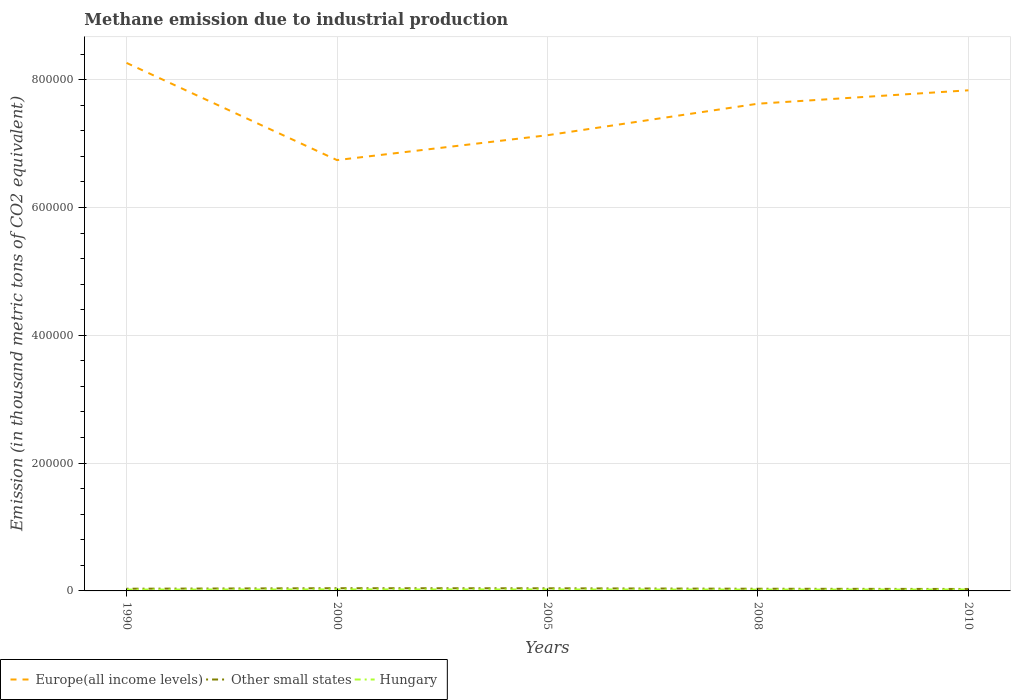How many different coloured lines are there?
Ensure brevity in your answer.  3. Does the line corresponding to Other small states intersect with the line corresponding to Hungary?
Your answer should be compact. No. Across all years, what is the maximum amount of methane emitted in Hungary?
Your answer should be compact. 2124.8. In which year was the amount of methane emitted in Europe(all income levels) maximum?
Provide a succinct answer. 2000. What is the total amount of methane emitted in Hungary in the graph?
Your answer should be compact. -249.9. What is the difference between the highest and the second highest amount of methane emitted in Europe(all income levels)?
Your answer should be compact. 1.52e+05. Is the amount of methane emitted in Europe(all income levels) strictly greater than the amount of methane emitted in Other small states over the years?
Keep it short and to the point. No. How many years are there in the graph?
Offer a very short reply. 5. What is the difference between two consecutive major ticks on the Y-axis?
Your response must be concise. 2.00e+05. Are the values on the major ticks of Y-axis written in scientific E-notation?
Ensure brevity in your answer.  No. Does the graph contain grids?
Your answer should be compact. Yes. What is the title of the graph?
Offer a very short reply. Methane emission due to industrial production. Does "France" appear as one of the legend labels in the graph?
Make the answer very short. No. What is the label or title of the Y-axis?
Ensure brevity in your answer.  Emission (in thousand metric tons of CO2 equivalent). What is the Emission (in thousand metric tons of CO2 equivalent) in Europe(all income levels) in 1990?
Provide a succinct answer. 8.26e+05. What is the Emission (in thousand metric tons of CO2 equivalent) in Other small states in 1990?
Keep it short and to the point. 3443.7. What is the Emission (in thousand metric tons of CO2 equivalent) of Hungary in 1990?
Give a very brief answer. 2124.8. What is the Emission (in thousand metric tons of CO2 equivalent) in Europe(all income levels) in 2000?
Offer a very short reply. 6.74e+05. What is the Emission (in thousand metric tons of CO2 equivalent) in Other small states in 2000?
Your response must be concise. 4229.4. What is the Emission (in thousand metric tons of CO2 equivalent) in Hungary in 2000?
Offer a terse response. 2374.7. What is the Emission (in thousand metric tons of CO2 equivalent) in Europe(all income levels) in 2005?
Keep it short and to the point. 7.13e+05. What is the Emission (in thousand metric tons of CO2 equivalent) of Other small states in 2005?
Ensure brevity in your answer.  4102.8. What is the Emission (in thousand metric tons of CO2 equivalent) in Hungary in 2005?
Keep it short and to the point. 2316.5. What is the Emission (in thousand metric tons of CO2 equivalent) of Europe(all income levels) in 2008?
Ensure brevity in your answer.  7.62e+05. What is the Emission (in thousand metric tons of CO2 equivalent) of Other small states in 2008?
Provide a short and direct response. 3410. What is the Emission (in thousand metric tons of CO2 equivalent) in Hungary in 2008?
Offer a terse response. 2129.8. What is the Emission (in thousand metric tons of CO2 equivalent) of Europe(all income levels) in 2010?
Keep it short and to the point. 7.83e+05. What is the Emission (in thousand metric tons of CO2 equivalent) of Other small states in 2010?
Offer a very short reply. 3052.1. What is the Emission (in thousand metric tons of CO2 equivalent) in Hungary in 2010?
Keep it short and to the point. 2241.2. Across all years, what is the maximum Emission (in thousand metric tons of CO2 equivalent) in Europe(all income levels)?
Make the answer very short. 8.26e+05. Across all years, what is the maximum Emission (in thousand metric tons of CO2 equivalent) in Other small states?
Provide a succinct answer. 4229.4. Across all years, what is the maximum Emission (in thousand metric tons of CO2 equivalent) in Hungary?
Make the answer very short. 2374.7. Across all years, what is the minimum Emission (in thousand metric tons of CO2 equivalent) in Europe(all income levels)?
Make the answer very short. 6.74e+05. Across all years, what is the minimum Emission (in thousand metric tons of CO2 equivalent) in Other small states?
Offer a terse response. 3052.1. Across all years, what is the minimum Emission (in thousand metric tons of CO2 equivalent) in Hungary?
Give a very brief answer. 2124.8. What is the total Emission (in thousand metric tons of CO2 equivalent) in Europe(all income levels) in the graph?
Offer a very short reply. 3.76e+06. What is the total Emission (in thousand metric tons of CO2 equivalent) of Other small states in the graph?
Ensure brevity in your answer.  1.82e+04. What is the total Emission (in thousand metric tons of CO2 equivalent) of Hungary in the graph?
Offer a very short reply. 1.12e+04. What is the difference between the Emission (in thousand metric tons of CO2 equivalent) in Europe(all income levels) in 1990 and that in 2000?
Provide a short and direct response. 1.52e+05. What is the difference between the Emission (in thousand metric tons of CO2 equivalent) of Other small states in 1990 and that in 2000?
Your answer should be very brief. -785.7. What is the difference between the Emission (in thousand metric tons of CO2 equivalent) of Hungary in 1990 and that in 2000?
Your response must be concise. -249.9. What is the difference between the Emission (in thousand metric tons of CO2 equivalent) in Europe(all income levels) in 1990 and that in 2005?
Your answer should be compact. 1.13e+05. What is the difference between the Emission (in thousand metric tons of CO2 equivalent) of Other small states in 1990 and that in 2005?
Provide a succinct answer. -659.1. What is the difference between the Emission (in thousand metric tons of CO2 equivalent) of Hungary in 1990 and that in 2005?
Provide a short and direct response. -191.7. What is the difference between the Emission (in thousand metric tons of CO2 equivalent) in Europe(all income levels) in 1990 and that in 2008?
Offer a very short reply. 6.38e+04. What is the difference between the Emission (in thousand metric tons of CO2 equivalent) in Other small states in 1990 and that in 2008?
Make the answer very short. 33.7. What is the difference between the Emission (in thousand metric tons of CO2 equivalent) of Europe(all income levels) in 1990 and that in 2010?
Your response must be concise. 4.29e+04. What is the difference between the Emission (in thousand metric tons of CO2 equivalent) in Other small states in 1990 and that in 2010?
Give a very brief answer. 391.6. What is the difference between the Emission (in thousand metric tons of CO2 equivalent) in Hungary in 1990 and that in 2010?
Keep it short and to the point. -116.4. What is the difference between the Emission (in thousand metric tons of CO2 equivalent) in Europe(all income levels) in 2000 and that in 2005?
Ensure brevity in your answer.  -3.89e+04. What is the difference between the Emission (in thousand metric tons of CO2 equivalent) of Other small states in 2000 and that in 2005?
Provide a short and direct response. 126.6. What is the difference between the Emission (in thousand metric tons of CO2 equivalent) in Hungary in 2000 and that in 2005?
Provide a succinct answer. 58.2. What is the difference between the Emission (in thousand metric tons of CO2 equivalent) in Europe(all income levels) in 2000 and that in 2008?
Offer a very short reply. -8.82e+04. What is the difference between the Emission (in thousand metric tons of CO2 equivalent) in Other small states in 2000 and that in 2008?
Ensure brevity in your answer.  819.4. What is the difference between the Emission (in thousand metric tons of CO2 equivalent) of Hungary in 2000 and that in 2008?
Provide a short and direct response. 244.9. What is the difference between the Emission (in thousand metric tons of CO2 equivalent) in Europe(all income levels) in 2000 and that in 2010?
Your answer should be very brief. -1.09e+05. What is the difference between the Emission (in thousand metric tons of CO2 equivalent) of Other small states in 2000 and that in 2010?
Offer a terse response. 1177.3. What is the difference between the Emission (in thousand metric tons of CO2 equivalent) of Hungary in 2000 and that in 2010?
Make the answer very short. 133.5. What is the difference between the Emission (in thousand metric tons of CO2 equivalent) of Europe(all income levels) in 2005 and that in 2008?
Keep it short and to the point. -4.93e+04. What is the difference between the Emission (in thousand metric tons of CO2 equivalent) in Other small states in 2005 and that in 2008?
Your answer should be very brief. 692.8. What is the difference between the Emission (in thousand metric tons of CO2 equivalent) of Hungary in 2005 and that in 2008?
Offer a terse response. 186.7. What is the difference between the Emission (in thousand metric tons of CO2 equivalent) of Europe(all income levels) in 2005 and that in 2010?
Your answer should be compact. -7.03e+04. What is the difference between the Emission (in thousand metric tons of CO2 equivalent) in Other small states in 2005 and that in 2010?
Keep it short and to the point. 1050.7. What is the difference between the Emission (in thousand metric tons of CO2 equivalent) of Hungary in 2005 and that in 2010?
Your answer should be compact. 75.3. What is the difference between the Emission (in thousand metric tons of CO2 equivalent) of Europe(all income levels) in 2008 and that in 2010?
Your answer should be compact. -2.10e+04. What is the difference between the Emission (in thousand metric tons of CO2 equivalent) of Other small states in 2008 and that in 2010?
Provide a succinct answer. 357.9. What is the difference between the Emission (in thousand metric tons of CO2 equivalent) of Hungary in 2008 and that in 2010?
Provide a short and direct response. -111.4. What is the difference between the Emission (in thousand metric tons of CO2 equivalent) in Europe(all income levels) in 1990 and the Emission (in thousand metric tons of CO2 equivalent) in Other small states in 2000?
Your answer should be compact. 8.22e+05. What is the difference between the Emission (in thousand metric tons of CO2 equivalent) in Europe(all income levels) in 1990 and the Emission (in thousand metric tons of CO2 equivalent) in Hungary in 2000?
Offer a very short reply. 8.24e+05. What is the difference between the Emission (in thousand metric tons of CO2 equivalent) in Other small states in 1990 and the Emission (in thousand metric tons of CO2 equivalent) in Hungary in 2000?
Your answer should be very brief. 1069. What is the difference between the Emission (in thousand metric tons of CO2 equivalent) in Europe(all income levels) in 1990 and the Emission (in thousand metric tons of CO2 equivalent) in Other small states in 2005?
Make the answer very short. 8.22e+05. What is the difference between the Emission (in thousand metric tons of CO2 equivalent) of Europe(all income levels) in 1990 and the Emission (in thousand metric tons of CO2 equivalent) of Hungary in 2005?
Offer a terse response. 8.24e+05. What is the difference between the Emission (in thousand metric tons of CO2 equivalent) in Other small states in 1990 and the Emission (in thousand metric tons of CO2 equivalent) in Hungary in 2005?
Make the answer very short. 1127.2. What is the difference between the Emission (in thousand metric tons of CO2 equivalent) in Europe(all income levels) in 1990 and the Emission (in thousand metric tons of CO2 equivalent) in Other small states in 2008?
Your response must be concise. 8.23e+05. What is the difference between the Emission (in thousand metric tons of CO2 equivalent) of Europe(all income levels) in 1990 and the Emission (in thousand metric tons of CO2 equivalent) of Hungary in 2008?
Make the answer very short. 8.24e+05. What is the difference between the Emission (in thousand metric tons of CO2 equivalent) of Other small states in 1990 and the Emission (in thousand metric tons of CO2 equivalent) of Hungary in 2008?
Your response must be concise. 1313.9. What is the difference between the Emission (in thousand metric tons of CO2 equivalent) of Europe(all income levels) in 1990 and the Emission (in thousand metric tons of CO2 equivalent) of Other small states in 2010?
Ensure brevity in your answer.  8.23e+05. What is the difference between the Emission (in thousand metric tons of CO2 equivalent) of Europe(all income levels) in 1990 and the Emission (in thousand metric tons of CO2 equivalent) of Hungary in 2010?
Give a very brief answer. 8.24e+05. What is the difference between the Emission (in thousand metric tons of CO2 equivalent) in Other small states in 1990 and the Emission (in thousand metric tons of CO2 equivalent) in Hungary in 2010?
Give a very brief answer. 1202.5. What is the difference between the Emission (in thousand metric tons of CO2 equivalent) of Europe(all income levels) in 2000 and the Emission (in thousand metric tons of CO2 equivalent) of Other small states in 2005?
Give a very brief answer. 6.70e+05. What is the difference between the Emission (in thousand metric tons of CO2 equivalent) in Europe(all income levels) in 2000 and the Emission (in thousand metric tons of CO2 equivalent) in Hungary in 2005?
Your response must be concise. 6.72e+05. What is the difference between the Emission (in thousand metric tons of CO2 equivalent) of Other small states in 2000 and the Emission (in thousand metric tons of CO2 equivalent) of Hungary in 2005?
Offer a very short reply. 1912.9. What is the difference between the Emission (in thousand metric tons of CO2 equivalent) of Europe(all income levels) in 2000 and the Emission (in thousand metric tons of CO2 equivalent) of Other small states in 2008?
Give a very brief answer. 6.71e+05. What is the difference between the Emission (in thousand metric tons of CO2 equivalent) in Europe(all income levels) in 2000 and the Emission (in thousand metric tons of CO2 equivalent) in Hungary in 2008?
Give a very brief answer. 6.72e+05. What is the difference between the Emission (in thousand metric tons of CO2 equivalent) of Other small states in 2000 and the Emission (in thousand metric tons of CO2 equivalent) of Hungary in 2008?
Your answer should be very brief. 2099.6. What is the difference between the Emission (in thousand metric tons of CO2 equivalent) of Europe(all income levels) in 2000 and the Emission (in thousand metric tons of CO2 equivalent) of Other small states in 2010?
Ensure brevity in your answer.  6.71e+05. What is the difference between the Emission (in thousand metric tons of CO2 equivalent) of Europe(all income levels) in 2000 and the Emission (in thousand metric tons of CO2 equivalent) of Hungary in 2010?
Make the answer very short. 6.72e+05. What is the difference between the Emission (in thousand metric tons of CO2 equivalent) in Other small states in 2000 and the Emission (in thousand metric tons of CO2 equivalent) in Hungary in 2010?
Your response must be concise. 1988.2. What is the difference between the Emission (in thousand metric tons of CO2 equivalent) in Europe(all income levels) in 2005 and the Emission (in thousand metric tons of CO2 equivalent) in Other small states in 2008?
Keep it short and to the point. 7.10e+05. What is the difference between the Emission (in thousand metric tons of CO2 equivalent) of Europe(all income levels) in 2005 and the Emission (in thousand metric tons of CO2 equivalent) of Hungary in 2008?
Give a very brief answer. 7.11e+05. What is the difference between the Emission (in thousand metric tons of CO2 equivalent) of Other small states in 2005 and the Emission (in thousand metric tons of CO2 equivalent) of Hungary in 2008?
Make the answer very short. 1973. What is the difference between the Emission (in thousand metric tons of CO2 equivalent) of Europe(all income levels) in 2005 and the Emission (in thousand metric tons of CO2 equivalent) of Other small states in 2010?
Offer a terse response. 7.10e+05. What is the difference between the Emission (in thousand metric tons of CO2 equivalent) of Europe(all income levels) in 2005 and the Emission (in thousand metric tons of CO2 equivalent) of Hungary in 2010?
Give a very brief answer. 7.11e+05. What is the difference between the Emission (in thousand metric tons of CO2 equivalent) of Other small states in 2005 and the Emission (in thousand metric tons of CO2 equivalent) of Hungary in 2010?
Give a very brief answer. 1861.6. What is the difference between the Emission (in thousand metric tons of CO2 equivalent) in Europe(all income levels) in 2008 and the Emission (in thousand metric tons of CO2 equivalent) in Other small states in 2010?
Ensure brevity in your answer.  7.59e+05. What is the difference between the Emission (in thousand metric tons of CO2 equivalent) in Europe(all income levels) in 2008 and the Emission (in thousand metric tons of CO2 equivalent) in Hungary in 2010?
Give a very brief answer. 7.60e+05. What is the difference between the Emission (in thousand metric tons of CO2 equivalent) of Other small states in 2008 and the Emission (in thousand metric tons of CO2 equivalent) of Hungary in 2010?
Your answer should be very brief. 1168.8. What is the average Emission (in thousand metric tons of CO2 equivalent) in Europe(all income levels) per year?
Your response must be concise. 7.52e+05. What is the average Emission (in thousand metric tons of CO2 equivalent) in Other small states per year?
Keep it short and to the point. 3647.6. What is the average Emission (in thousand metric tons of CO2 equivalent) in Hungary per year?
Offer a terse response. 2237.4. In the year 1990, what is the difference between the Emission (in thousand metric tons of CO2 equivalent) in Europe(all income levels) and Emission (in thousand metric tons of CO2 equivalent) in Other small states?
Ensure brevity in your answer.  8.23e+05. In the year 1990, what is the difference between the Emission (in thousand metric tons of CO2 equivalent) in Europe(all income levels) and Emission (in thousand metric tons of CO2 equivalent) in Hungary?
Give a very brief answer. 8.24e+05. In the year 1990, what is the difference between the Emission (in thousand metric tons of CO2 equivalent) of Other small states and Emission (in thousand metric tons of CO2 equivalent) of Hungary?
Your answer should be compact. 1318.9. In the year 2000, what is the difference between the Emission (in thousand metric tons of CO2 equivalent) of Europe(all income levels) and Emission (in thousand metric tons of CO2 equivalent) of Other small states?
Offer a very short reply. 6.70e+05. In the year 2000, what is the difference between the Emission (in thousand metric tons of CO2 equivalent) in Europe(all income levels) and Emission (in thousand metric tons of CO2 equivalent) in Hungary?
Your answer should be very brief. 6.72e+05. In the year 2000, what is the difference between the Emission (in thousand metric tons of CO2 equivalent) of Other small states and Emission (in thousand metric tons of CO2 equivalent) of Hungary?
Make the answer very short. 1854.7. In the year 2005, what is the difference between the Emission (in thousand metric tons of CO2 equivalent) of Europe(all income levels) and Emission (in thousand metric tons of CO2 equivalent) of Other small states?
Your response must be concise. 7.09e+05. In the year 2005, what is the difference between the Emission (in thousand metric tons of CO2 equivalent) of Europe(all income levels) and Emission (in thousand metric tons of CO2 equivalent) of Hungary?
Make the answer very short. 7.11e+05. In the year 2005, what is the difference between the Emission (in thousand metric tons of CO2 equivalent) of Other small states and Emission (in thousand metric tons of CO2 equivalent) of Hungary?
Offer a terse response. 1786.3. In the year 2008, what is the difference between the Emission (in thousand metric tons of CO2 equivalent) of Europe(all income levels) and Emission (in thousand metric tons of CO2 equivalent) of Other small states?
Provide a short and direct response. 7.59e+05. In the year 2008, what is the difference between the Emission (in thousand metric tons of CO2 equivalent) in Europe(all income levels) and Emission (in thousand metric tons of CO2 equivalent) in Hungary?
Your answer should be compact. 7.60e+05. In the year 2008, what is the difference between the Emission (in thousand metric tons of CO2 equivalent) of Other small states and Emission (in thousand metric tons of CO2 equivalent) of Hungary?
Provide a short and direct response. 1280.2. In the year 2010, what is the difference between the Emission (in thousand metric tons of CO2 equivalent) of Europe(all income levels) and Emission (in thousand metric tons of CO2 equivalent) of Other small states?
Your response must be concise. 7.80e+05. In the year 2010, what is the difference between the Emission (in thousand metric tons of CO2 equivalent) in Europe(all income levels) and Emission (in thousand metric tons of CO2 equivalent) in Hungary?
Your answer should be compact. 7.81e+05. In the year 2010, what is the difference between the Emission (in thousand metric tons of CO2 equivalent) of Other small states and Emission (in thousand metric tons of CO2 equivalent) of Hungary?
Your response must be concise. 810.9. What is the ratio of the Emission (in thousand metric tons of CO2 equivalent) in Europe(all income levels) in 1990 to that in 2000?
Ensure brevity in your answer.  1.23. What is the ratio of the Emission (in thousand metric tons of CO2 equivalent) in Other small states in 1990 to that in 2000?
Offer a very short reply. 0.81. What is the ratio of the Emission (in thousand metric tons of CO2 equivalent) of Hungary in 1990 to that in 2000?
Provide a succinct answer. 0.89. What is the ratio of the Emission (in thousand metric tons of CO2 equivalent) of Europe(all income levels) in 1990 to that in 2005?
Your response must be concise. 1.16. What is the ratio of the Emission (in thousand metric tons of CO2 equivalent) in Other small states in 1990 to that in 2005?
Your answer should be very brief. 0.84. What is the ratio of the Emission (in thousand metric tons of CO2 equivalent) in Hungary in 1990 to that in 2005?
Your response must be concise. 0.92. What is the ratio of the Emission (in thousand metric tons of CO2 equivalent) of Europe(all income levels) in 1990 to that in 2008?
Provide a succinct answer. 1.08. What is the ratio of the Emission (in thousand metric tons of CO2 equivalent) of Other small states in 1990 to that in 2008?
Provide a succinct answer. 1.01. What is the ratio of the Emission (in thousand metric tons of CO2 equivalent) of Europe(all income levels) in 1990 to that in 2010?
Offer a very short reply. 1.05. What is the ratio of the Emission (in thousand metric tons of CO2 equivalent) of Other small states in 1990 to that in 2010?
Ensure brevity in your answer.  1.13. What is the ratio of the Emission (in thousand metric tons of CO2 equivalent) of Hungary in 1990 to that in 2010?
Ensure brevity in your answer.  0.95. What is the ratio of the Emission (in thousand metric tons of CO2 equivalent) in Europe(all income levels) in 2000 to that in 2005?
Your answer should be very brief. 0.95. What is the ratio of the Emission (in thousand metric tons of CO2 equivalent) of Other small states in 2000 to that in 2005?
Your answer should be compact. 1.03. What is the ratio of the Emission (in thousand metric tons of CO2 equivalent) in Hungary in 2000 to that in 2005?
Your answer should be compact. 1.03. What is the ratio of the Emission (in thousand metric tons of CO2 equivalent) of Europe(all income levels) in 2000 to that in 2008?
Keep it short and to the point. 0.88. What is the ratio of the Emission (in thousand metric tons of CO2 equivalent) of Other small states in 2000 to that in 2008?
Offer a terse response. 1.24. What is the ratio of the Emission (in thousand metric tons of CO2 equivalent) in Hungary in 2000 to that in 2008?
Keep it short and to the point. 1.11. What is the ratio of the Emission (in thousand metric tons of CO2 equivalent) of Europe(all income levels) in 2000 to that in 2010?
Give a very brief answer. 0.86. What is the ratio of the Emission (in thousand metric tons of CO2 equivalent) in Other small states in 2000 to that in 2010?
Offer a terse response. 1.39. What is the ratio of the Emission (in thousand metric tons of CO2 equivalent) of Hungary in 2000 to that in 2010?
Provide a short and direct response. 1.06. What is the ratio of the Emission (in thousand metric tons of CO2 equivalent) of Europe(all income levels) in 2005 to that in 2008?
Give a very brief answer. 0.94. What is the ratio of the Emission (in thousand metric tons of CO2 equivalent) in Other small states in 2005 to that in 2008?
Provide a succinct answer. 1.2. What is the ratio of the Emission (in thousand metric tons of CO2 equivalent) of Hungary in 2005 to that in 2008?
Your answer should be very brief. 1.09. What is the ratio of the Emission (in thousand metric tons of CO2 equivalent) in Europe(all income levels) in 2005 to that in 2010?
Make the answer very short. 0.91. What is the ratio of the Emission (in thousand metric tons of CO2 equivalent) of Other small states in 2005 to that in 2010?
Provide a short and direct response. 1.34. What is the ratio of the Emission (in thousand metric tons of CO2 equivalent) in Hungary in 2005 to that in 2010?
Your response must be concise. 1.03. What is the ratio of the Emission (in thousand metric tons of CO2 equivalent) in Europe(all income levels) in 2008 to that in 2010?
Provide a succinct answer. 0.97. What is the ratio of the Emission (in thousand metric tons of CO2 equivalent) in Other small states in 2008 to that in 2010?
Make the answer very short. 1.12. What is the ratio of the Emission (in thousand metric tons of CO2 equivalent) in Hungary in 2008 to that in 2010?
Keep it short and to the point. 0.95. What is the difference between the highest and the second highest Emission (in thousand metric tons of CO2 equivalent) of Europe(all income levels)?
Provide a succinct answer. 4.29e+04. What is the difference between the highest and the second highest Emission (in thousand metric tons of CO2 equivalent) of Other small states?
Provide a short and direct response. 126.6. What is the difference between the highest and the second highest Emission (in thousand metric tons of CO2 equivalent) of Hungary?
Provide a short and direct response. 58.2. What is the difference between the highest and the lowest Emission (in thousand metric tons of CO2 equivalent) in Europe(all income levels)?
Offer a very short reply. 1.52e+05. What is the difference between the highest and the lowest Emission (in thousand metric tons of CO2 equivalent) in Other small states?
Keep it short and to the point. 1177.3. What is the difference between the highest and the lowest Emission (in thousand metric tons of CO2 equivalent) in Hungary?
Your response must be concise. 249.9. 